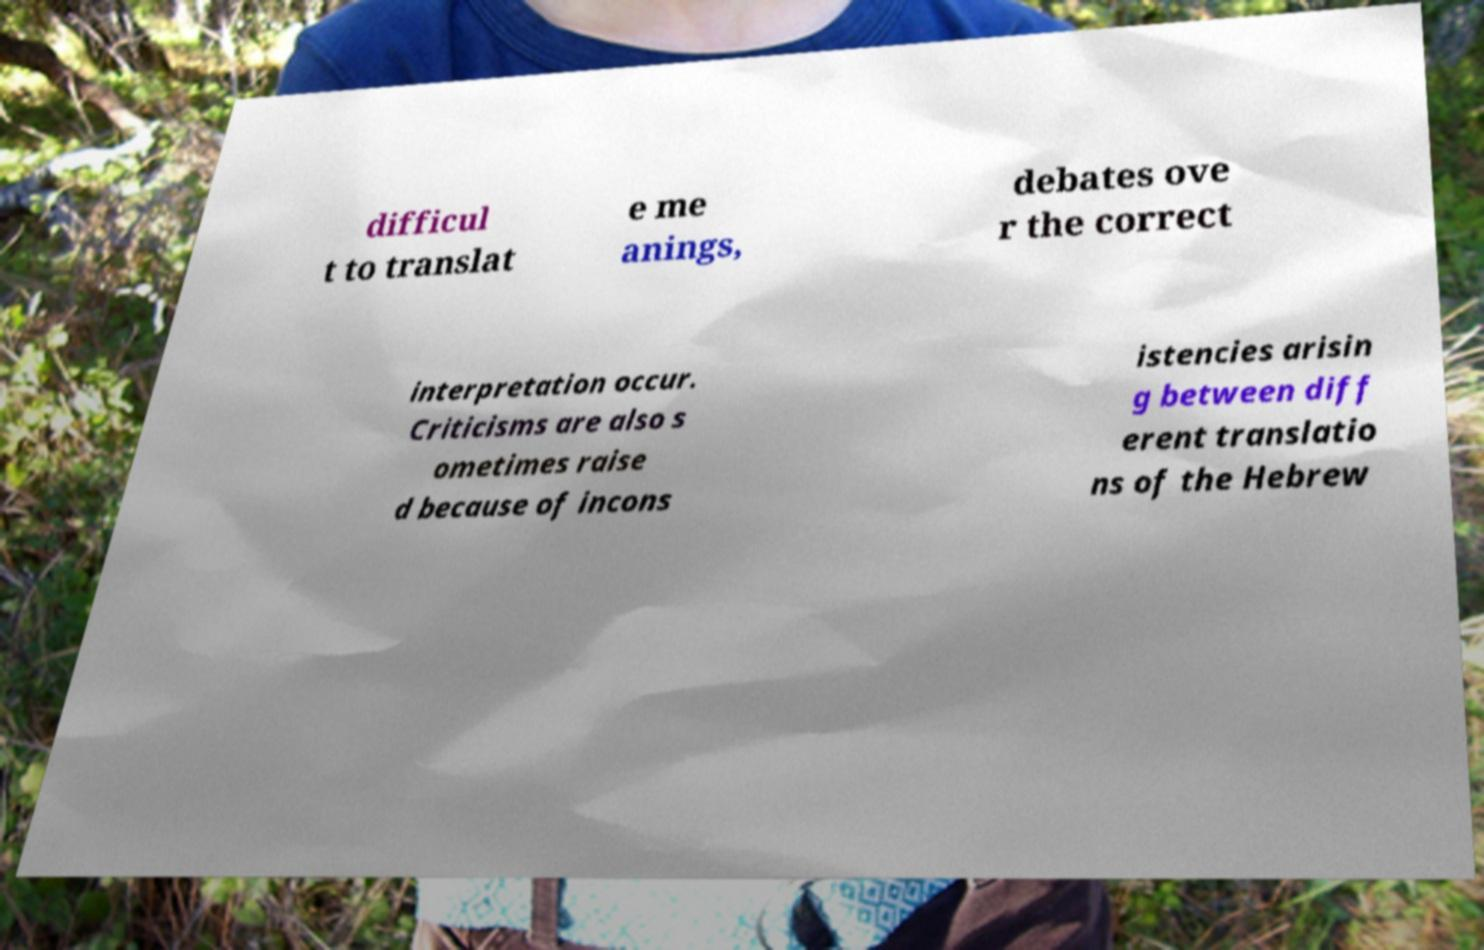Can you read and provide the text displayed in the image?This photo seems to have some interesting text. Can you extract and type it out for me? difficul t to translat e me anings, debates ove r the correct interpretation occur. Criticisms are also s ometimes raise d because of incons istencies arisin g between diff erent translatio ns of the Hebrew 